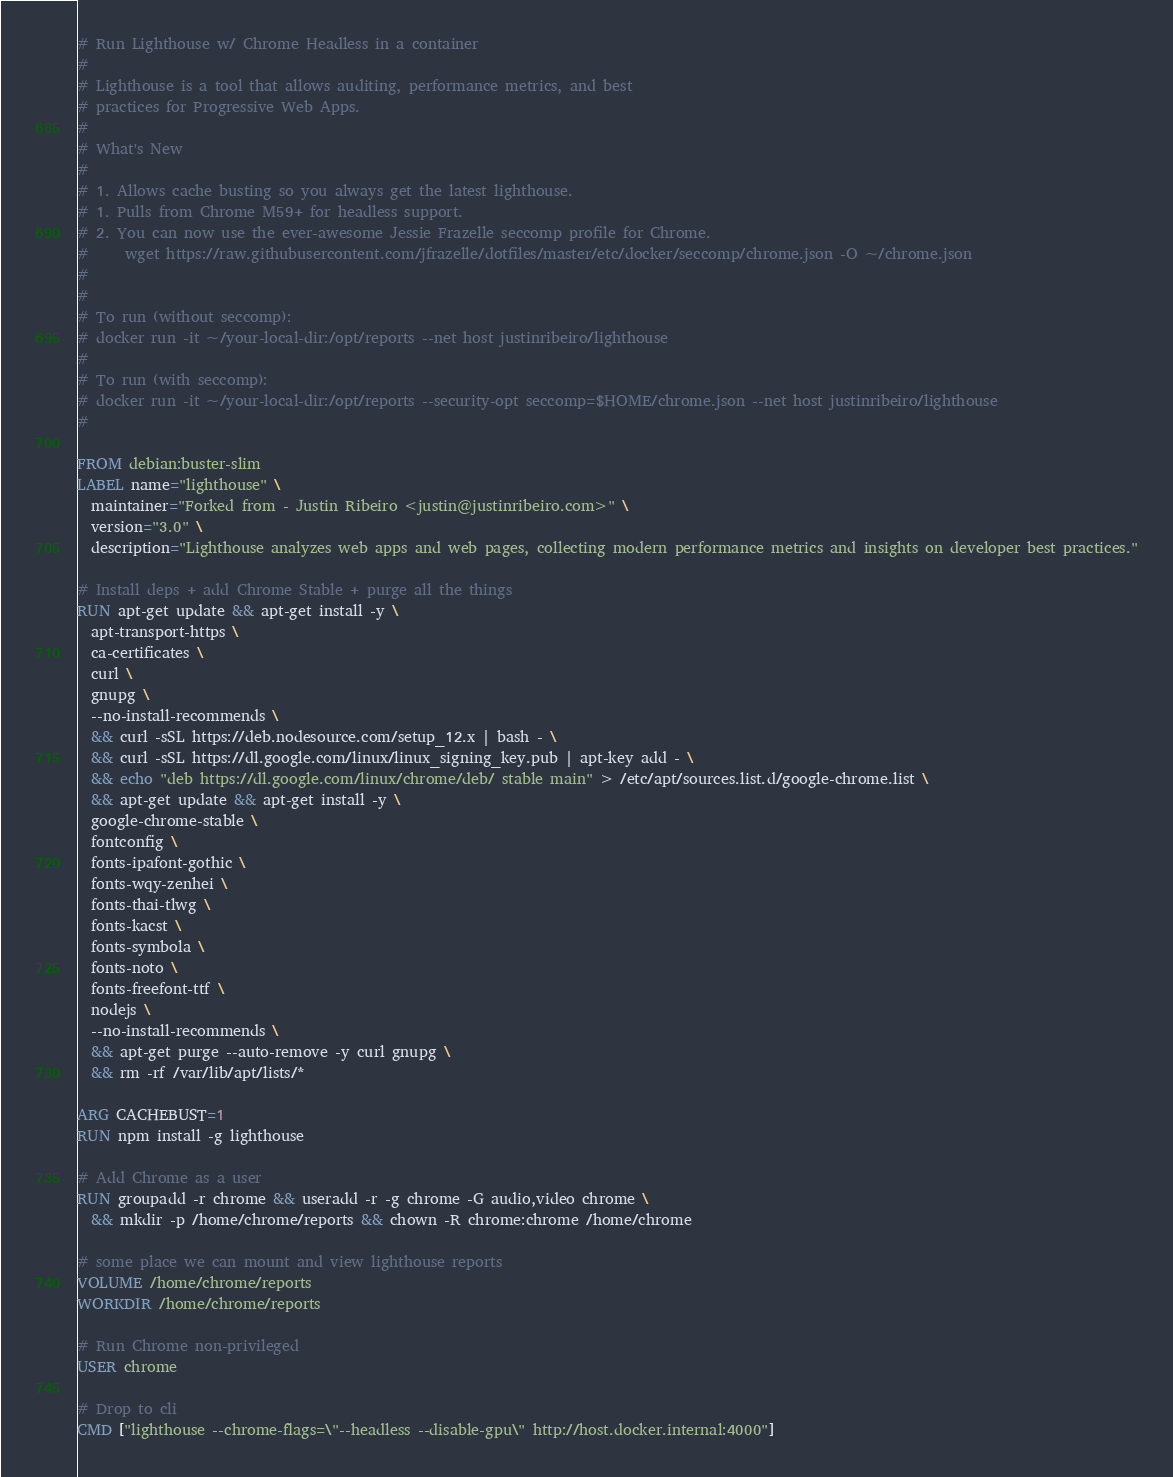Convert code to text. <code><loc_0><loc_0><loc_500><loc_500><_Dockerfile_># Run Lighthouse w/ Chrome Headless in a container
#
# Lighthouse is a tool that allows auditing, performance metrics, and best
# practices for Progressive Web Apps.
#
# What's New
#
# 1. Allows cache busting so you always get the latest lighthouse.
# 1. Pulls from Chrome M59+ for headless support.
# 2. You can now use the ever-awesome Jessie Frazelle seccomp profile for Chrome.
#     wget https://raw.githubusercontent.com/jfrazelle/dotfiles/master/etc/docker/seccomp/chrome.json -O ~/chrome.json
#
#
# To run (without seccomp):
# docker run -it ~/your-local-dir:/opt/reports --net host justinribeiro/lighthouse
#
# To run (with seccomp):
# docker run -it ~/your-local-dir:/opt/reports --security-opt seccomp=$HOME/chrome.json --net host justinribeiro/lighthouse
#

FROM debian:buster-slim
LABEL name="lighthouse" \
  maintainer="Forked from - Justin Ribeiro <justin@justinribeiro.com>" \
  version="3.0" \
  description="Lighthouse analyzes web apps and web pages, collecting modern performance metrics and insights on developer best practices."

# Install deps + add Chrome Stable + purge all the things
RUN apt-get update && apt-get install -y \
  apt-transport-https \
  ca-certificates \
  curl \
  gnupg \
  --no-install-recommends \
  && curl -sSL https://deb.nodesource.com/setup_12.x | bash - \
  && curl -sSL https://dl.google.com/linux/linux_signing_key.pub | apt-key add - \
  && echo "deb https://dl.google.com/linux/chrome/deb/ stable main" > /etc/apt/sources.list.d/google-chrome.list \
  && apt-get update && apt-get install -y \
  google-chrome-stable \
  fontconfig \
  fonts-ipafont-gothic \
  fonts-wqy-zenhei \
  fonts-thai-tlwg \
  fonts-kacst \
  fonts-symbola \
  fonts-noto \
  fonts-freefont-ttf \
  nodejs \
  --no-install-recommends \
  && apt-get purge --auto-remove -y curl gnupg \
  && rm -rf /var/lib/apt/lists/*

ARG CACHEBUST=1
RUN npm install -g lighthouse

# Add Chrome as a user
RUN groupadd -r chrome && useradd -r -g chrome -G audio,video chrome \
  && mkdir -p /home/chrome/reports && chown -R chrome:chrome /home/chrome

# some place we can mount and view lighthouse reports
VOLUME /home/chrome/reports
WORKDIR /home/chrome/reports

# Run Chrome non-privileged
USER chrome

# Drop to cli
CMD ["lighthouse --chrome-flags=\"--headless --disable-gpu\" http://host.docker.internal:4000"]
</code> 